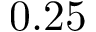<formula> <loc_0><loc_0><loc_500><loc_500>0 . 2 5</formula> 